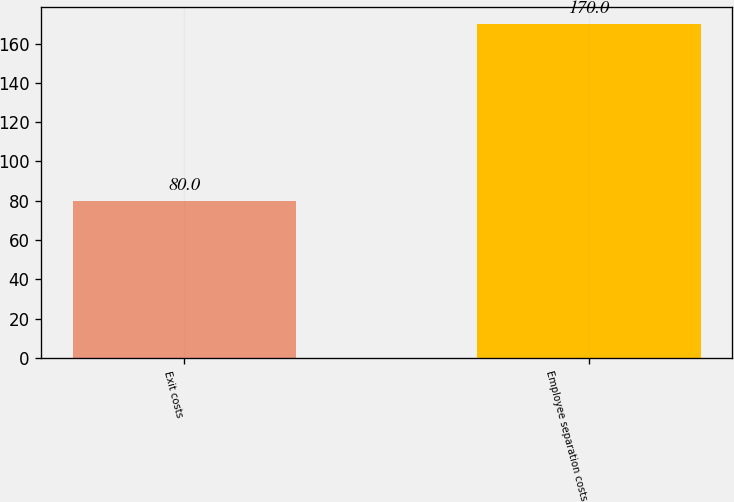Convert chart to OTSL. <chart><loc_0><loc_0><loc_500><loc_500><bar_chart><fcel>Exit costs<fcel>Employee separation costs<nl><fcel>80<fcel>170<nl></chart> 